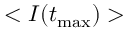<formula> <loc_0><loc_0><loc_500><loc_500>< I ( t _ { \max } ) ></formula> 